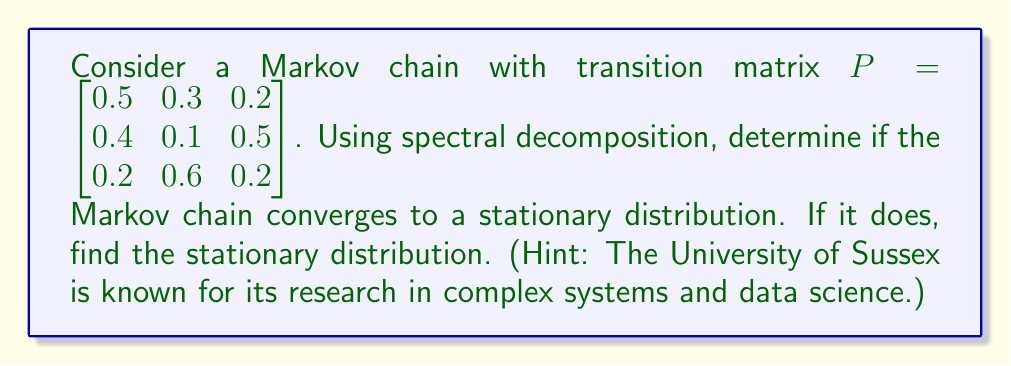Show me your answer to this math problem. 1. First, we need to find the eigenvalues and eigenvectors of the transition matrix $P$.

2. Solving the characteristic equation $\det(P - \lambda I) = 0$:
   $$\det\begin{bmatrix} 0.5-\lambda & 0.3 & 0.2 \\ 0.4 & 0.1-\lambda & 0.5 \\ 0.2 & 0.6 & 0.2-\lambda \end{bmatrix} = 0$$
   
   We get: $\lambda_1 = 1$, $\lambda_2 \approx -0.2854$, $\lambda_3 \approx 0.0854$

3. The Markov chain converges if and only if there is exactly one eigenvalue equal to 1, and all other eigenvalues have absolute value less than 1. This condition is satisfied here.

4. Now, we find the right eigenvector $v_1$ corresponding to $\lambda_1 = 1$:
   $$(P - I)v_1 = 0$$
   Solving this, we get: $v_1 \propto [1, 1.5, 1.25]^T$

5. Normalize $v_1$ to get the stationary distribution $\pi$:
   $$\pi = \frac{1}{1 + 1.5 + 1.25}[1, 1.5, 1.25]^T = [0.2667, 0.4, 0.3333]^T$$

6. We can verify that $\pi P = \pi$:
   $$[0.2667, 0.4, 0.3333] \begin{bmatrix} 0.5 & 0.3 & 0.2 \\ 0.4 & 0.1 & 0.5 \\ 0.2 & 0.6 & 0.2 \end{bmatrix} = [0.2667, 0.4, 0.3333]$$

Therefore, the Markov chain converges to the stationary distribution $\pi = [0.2667, 0.4, 0.3333]^T$.
Answer: Yes, converges to $[0.2667, 0.4, 0.3333]^T$ 